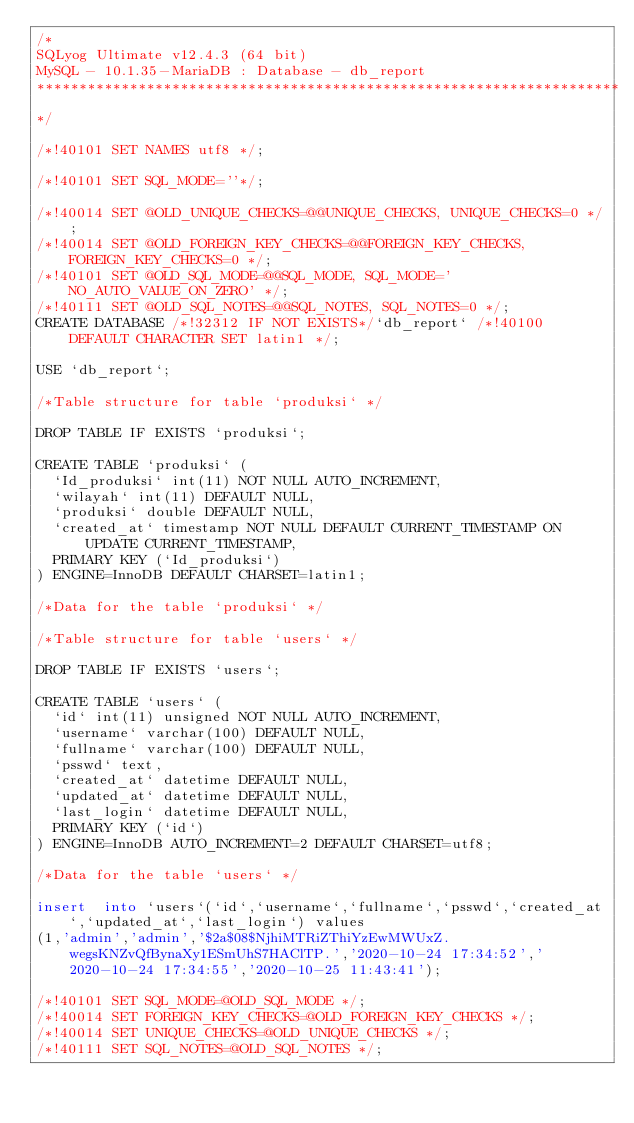<code> <loc_0><loc_0><loc_500><loc_500><_SQL_>/*
SQLyog Ultimate v12.4.3 (64 bit)
MySQL - 10.1.35-MariaDB : Database - db_report
*********************************************************************
*/

/*!40101 SET NAMES utf8 */;

/*!40101 SET SQL_MODE=''*/;

/*!40014 SET @OLD_UNIQUE_CHECKS=@@UNIQUE_CHECKS, UNIQUE_CHECKS=0 */;
/*!40014 SET @OLD_FOREIGN_KEY_CHECKS=@@FOREIGN_KEY_CHECKS, FOREIGN_KEY_CHECKS=0 */;
/*!40101 SET @OLD_SQL_MODE=@@SQL_MODE, SQL_MODE='NO_AUTO_VALUE_ON_ZERO' */;
/*!40111 SET @OLD_SQL_NOTES=@@SQL_NOTES, SQL_NOTES=0 */;
CREATE DATABASE /*!32312 IF NOT EXISTS*/`db_report` /*!40100 DEFAULT CHARACTER SET latin1 */;

USE `db_report`;

/*Table structure for table `produksi` */

DROP TABLE IF EXISTS `produksi`;

CREATE TABLE `produksi` (
  `Id_produksi` int(11) NOT NULL AUTO_INCREMENT,
  `wilayah` int(11) DEFAULT NULL,
  `produksi` double DEFAULT NULL,
  `created_at` timestamp NOT NULL DEFAULT CURRENT_TIMESTAMP ON UPDATE CURRENT_TIMESTAMP,
  PRIMARY KEY (`Id_produksi`)
) ENGINE=InnoDB DEFAULT CHARSET=latin1;

/*Data for the table `produksi` */

/*Table structure for table `users` */

DROP TABLE IF EXISTS `users`;

CREATE TABLE `users` (
  `id` int(11) unsigned NOT NULL AUTO_INCREMENT,
  `username` varchar(100) DEFAULT NULL,
  `fullname` varchar(100) DEFAULT NULL,
  `psswd` text,
  `created_at` datetime DEFAULT NULL,
  `updated_at` datetime DEFAULT NULL,
  `last_login` datetime DEFAULT NULL,
  PRIMARY KEY (`id`)
) ENGINE=InnoDB AUTO_INCREMENT=2 DEFAULT CHARSET=utf8;

/*Data for the table `users` */

insert  into `users`(`id`,`username`,`fullname`,`psswd`,`created_at`,`updated_at`,`last_login`) values 
(1,'admin','admin','$2a$08$NjhiMTRiZThiYzEwMWUxZ.wegsKNZvQfBynaXy1ESmUhS7HAClTP.','2020-10-24 17:34:52','2020-10-24 17:34:55','2020-10-25 11:43:41');

/*!40101 SET SQL_MODE=@OLD_SQL_MODE */;
/*!40014 SET FOREIGN_KEY_CHECKS=@OLD_FOREIGN_KEY_CHECKS */;
/*!40014 SET UNIQUE_CHECKS=@OLD_UNIQUE_CHECKS */;
/*!40111 SET SQL_NOTES=@OLD_SQL_NOTES */;
</code> 